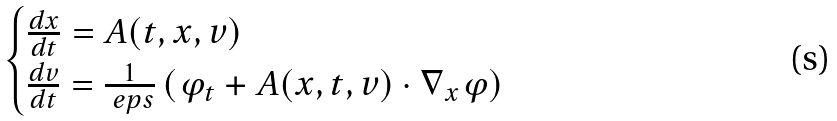Convert formula to latex. <formula><loc_0><loc_0><loc_500><loc_500>\begin{cases} \frac { d x } { d t } = A ( t , x , v ) & \\ \frac { d v } { d t } = \frac { 1 } { \ e p s } \left ( \varphi _ { t } + A ( x , t , v ) \cdot \nabla _ { x } \varphi \right ) \end{cases}</formula> 